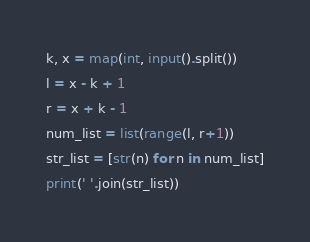<code> <loc_0><loc_0><loc_500><loc_500><_Python_>k, x = map(int, input().split())
l = x - k + 1
r = x + k - 1
num_list = list(range(l, r+1))
str_list = [str(n) for n in num_list]
print(' '.join(str_list))
</code> 